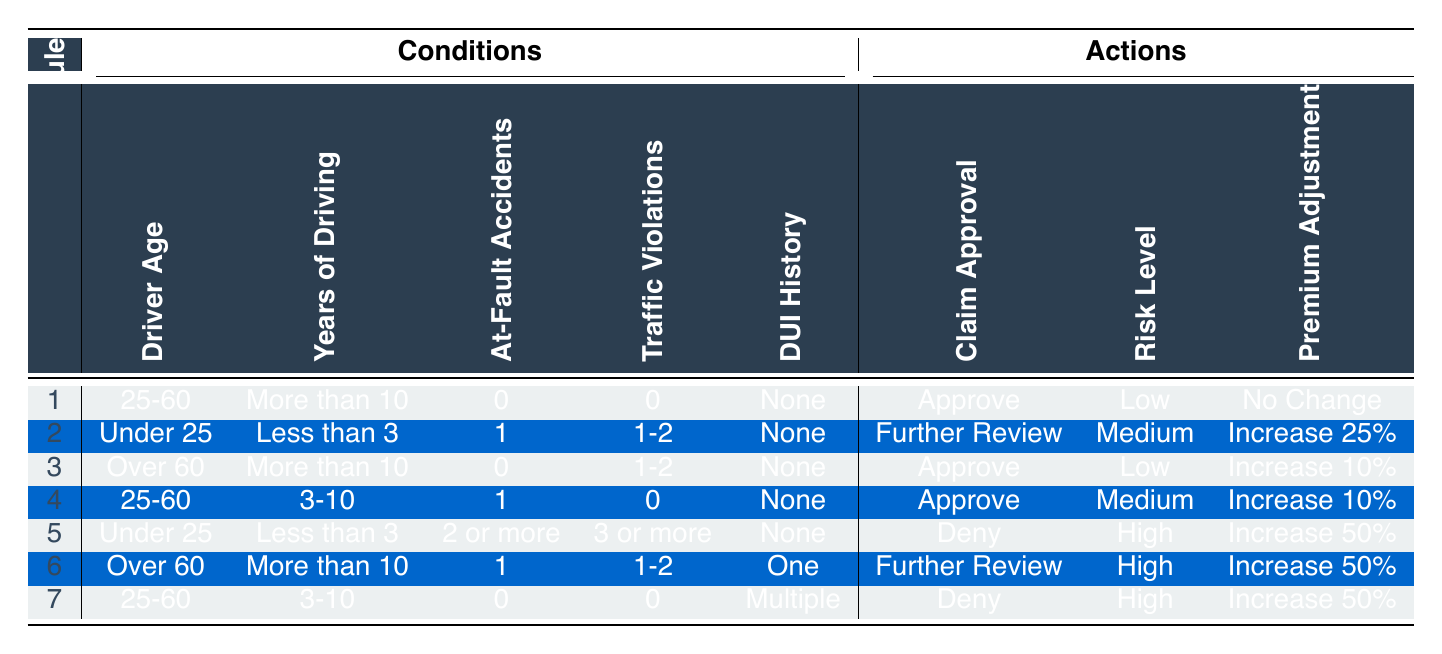What is the claim approval status for a driver aged 25-60 with more than 10 years of driving experience, 0 at-fault accidents, 0 traffic violations, and no DUI history? According to Row 1 in the table, the conditions match and the corresponding actions indicate that the claim should be "Approve".
Answer: Approve How many drivers in the table face a "Deny" claim approval status? There are 3 rows (Row 5 and Row 7) in the table where the claim approval status is marked as "Deny".
Answer: 2 Is it true that an individual with under 25 years of age, less than 3 years of driving experience, and 2 or more at-fault accidents would always be denied? The table in Row 5 shows that these conditions do lead to a "Deny" claim status. Therefore, based on the given rules, it is true.
Answer: Yes What is the risk level associated with a driver over 60 years old who has more than 10 years of experience but has 1 at-fault accident and 1-2 traffic violations with a DUI history of one? In Row 6, under those conditions, the risk level is specified as "High".
Answer: High If a driver is under 25, has less than three years of driving experience, 1 at-fault accident, and 1-2 traffic violations, what is the premium adjustment? According to Row 2, these conditions lead to an action of "Increase 25%".
Answer: Increase 25% What are the actions for a driver aged 25-60 with 3-10 years of driving experience who has 1 at-fault accident and 0 traffic violations but a DUI history of multiple incidents? Checking Row 7 indicates that for these conditions, the actions are "Deny", "High", and "Increase 50%".
Answer: Deny, High, Increase 50% What is the average premium adjustment across all rows for drivers with a claim approval status of "Approve"? The relevant premium adjustments for rows with "Approve" are: No Change (Row 1), Increase 10% (Row 3), Increase 10% (Row 4). Adding these values (0% + 10% + 10%) gives 20%. Dividing by 3 yields an average of approximately 6.67%.
Answer: 6.67% How many conditions would lead to a claim approval status of "Further Review"? Only 2 rows (Row 2 and Row 6) show a status of "Further Review". Thus, there are 2 conditions leading to this status.
Answer: 2 What is the risk level for a driver over 60 years of age with 0 at-fault accidents and more than 10 years of driving experience? From Row 3 of the table, this combination results in a risk level of "Low".
Answer: Low 